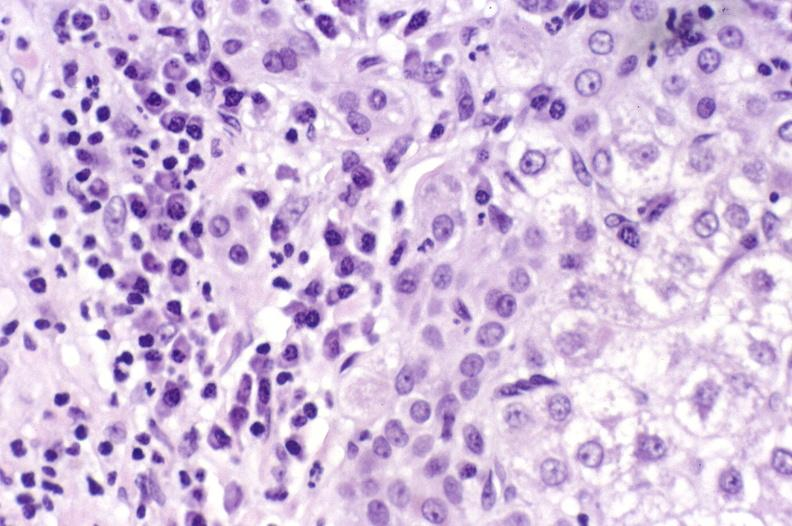what is present?
Answer the question using a single word or phrase. Liver 